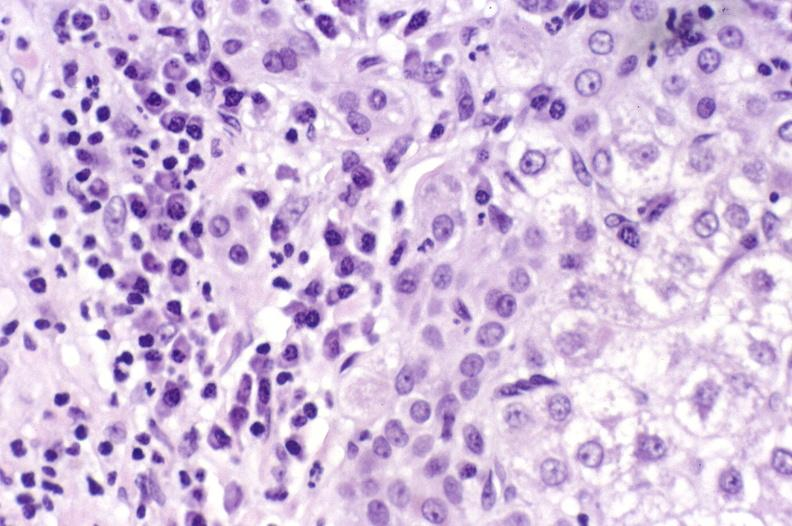what is present?
Answer the question using a single word or phrase. Liver 